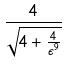<formula> <loc_0><loc_0><loc_500><loc_500>\frac { 4 } { \sqrt { 4 + \frac { 4 } { \epsilon ^ { 9 } } } }</formula> 